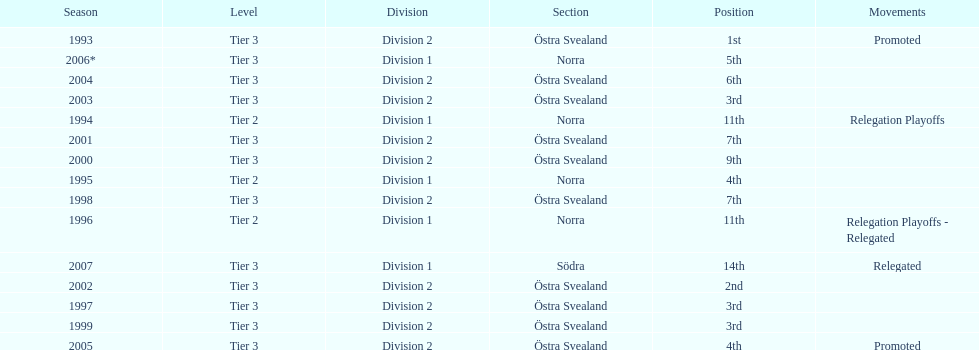How many times is division 2 listed as the division? 10. 